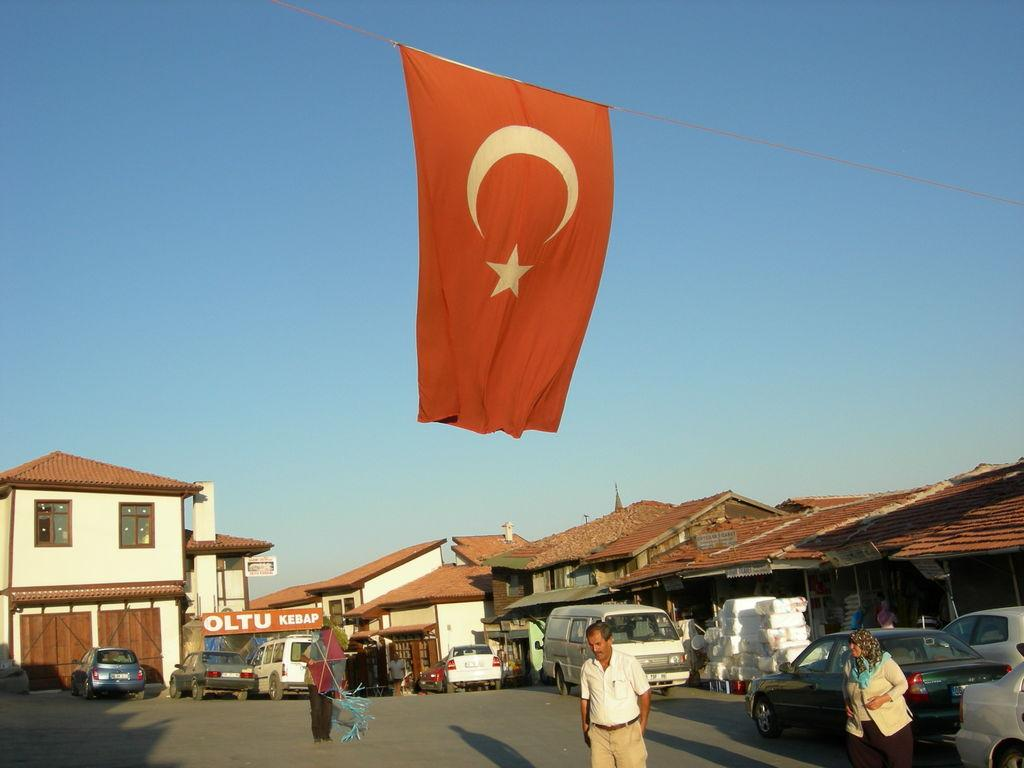Who or what can be seen in the image? There are people in the image. What else is visible on the road in the image? There are vehicles on the road in the image. What type of structures are present in the image? There are houses in the image. What is attached to the rope in the image? There is a flag on a rope in the image. What are the boards used for in the image? The boards are present in the image, but their purpose is not clear from the facts provided. What is visible in the background of the image? The sky is visible in the background of the image. How do the geese feel about the pleasure they derive from the trick in the image? There are no geese or tricks present in the image, so this question cannot be answered. 